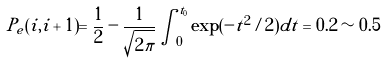Convert formula to latex. <formula><loc_0><loc_0><loc_500><loc_500>P _ { e } ( i , i + 1 ) = \frac { 1 } { 2 } - \frac { 1 } { \sqrt { 2 \pi } } \int _ { 0 } ^ { t _ { 0 } } \exp ( - t ^ { 2 } / 2 ) d t = 0 . 2 \sim 0 . 5</formula> 